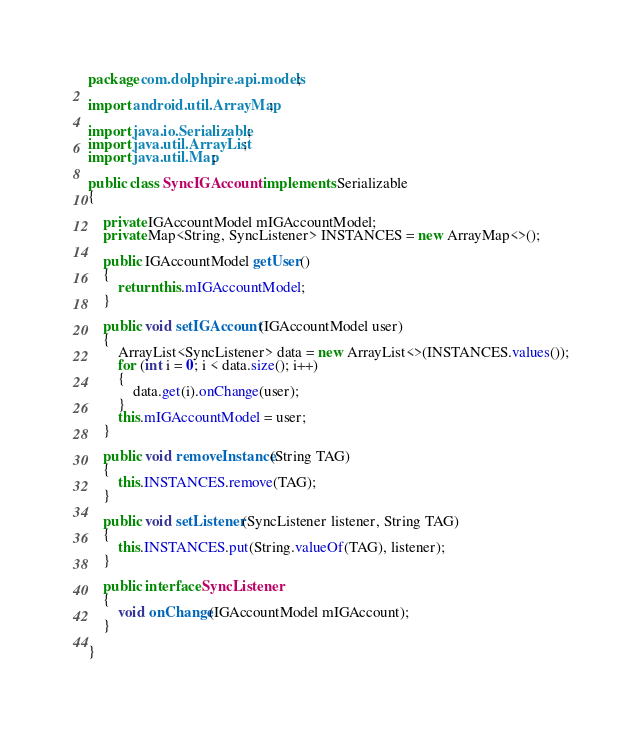Convert code to text. <code><loc_0><loc_0><loc_500><loc_500><_Java_>package com.dolphpire.api.models;

import android.util.ArrayMap;

import java.io.Serializable;
import java.util.ArrayList;
import java.util.Map;

public class SyncIGAccount implements Serializable
{

    private IGAccountModel mIGAccountModel;
    private Map<String, SyncListener> INSTANCES = new ArrayMap<>();

    public IGAccountModel getUser()
    {
        return this.mIGAccountModel;
    }

    public void setIGAccount(IGAccountModel user)
    {
        ArrayList<SyncListener> data = new ArrayList<>(INSTANCES.values());
        for (int i = 0; i < data.size(); i++)
        {
            data.get(i).onChange(user);
        }
        this.mIGAccountModel = user;
    }

    public void removeInstance(String TAG)
    {
        this.INSTANCES.remove(TAG);
    }

    public void setListener(SyncListener listener, String TAG)
    {
        this.INSTANCES.put(String.valueOf(TAG), listener);
    }

    public interface SyncListener
    {
        void onChange(IGAccountModel mIGAccount);
    }

}</code> 